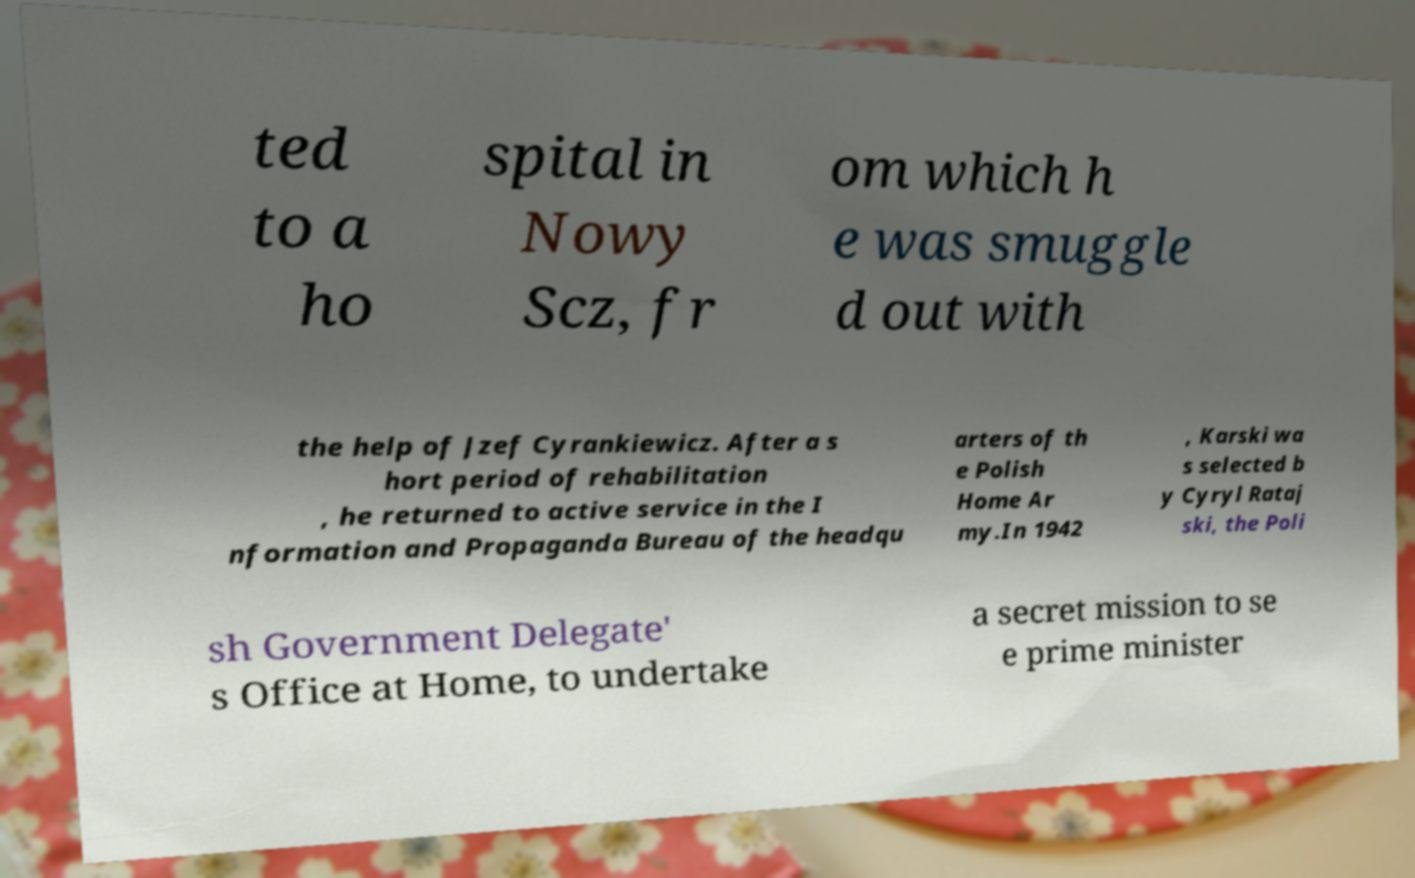What messages or text are displayed in this image? I need them in a readable, typed format. ted to a ho spital in Nowy Scz, fr om which h e was smuggle d out with the help of Jzef Cyrankiewicz. After a s hort period of rehabilitation , he returned to active service in the I nformation and Propaganda Bureau of the headqu arters of th e Polish Home Ar my.In 1942 , Karski wa s selected b y Cyryl Rataj ski, the Poli sh Government Delegate' s Office at Home, to undertake a secret mission to se e prime minister 